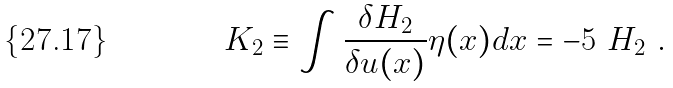<formula> <loc_0><loc_0><loc_500><loc_500>K _ { 2 } \equiv \int \frac { \delta H _ { 2 } } { \delta u ( x ) } \eta ( x ) d x = - 5 \ H _ { 2 } \ .</formula> 